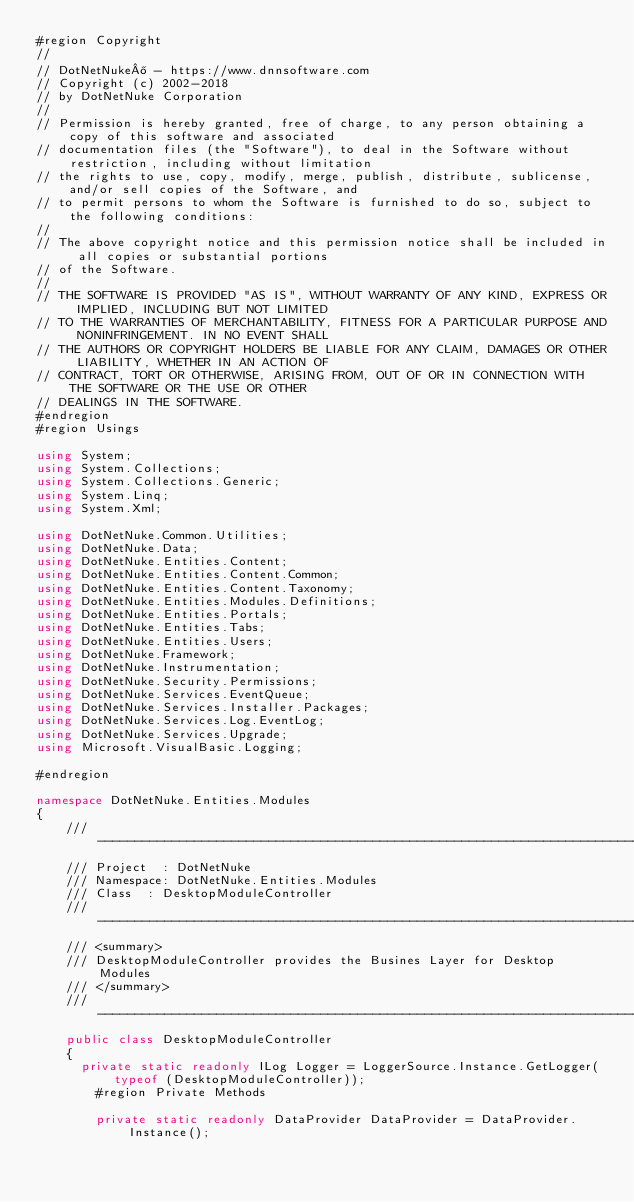<code> <loc_0><loc_0><loc_500><loc_500><_C#_>#region Copyright
// 
// DotNetNuke® - https://www.dnnsoftware.com
// Copyright (c) 2002-2018
// by DotNetNuke Corporation
// 
// Permission is hereby granted, free of charge, to any person obtaining a copy of this software and associated 
// documentation files (the "Software"), to deal in the Software without restriction, including without limitation 
// the rights to use, copy, modify, merge, publish, distribute, sublicense, and/or sell copies of the Software, and 
// to permit persons to whom the Software is furnished to do so, subject to the following conditions:
// 
// The above copyright notice and this permission notice shall be included in all copies or substantial portions 
// of the Software.
// 
// THE SOFTWARE IS PROVIDED "AS IS", WITHOUT WARRANTY OF ANY KIND, EXPRESS OR IMPLIED, INCLUDING BUT NOT LIMITED 
// TO THE WARRANTIES OF MERCHANTABILITY, FITNESS FOR A PARTICULAR PURPOSE AND NONINFRINGEMENT. IN NO EVENT SHALL 
// THE AUTHORS OR COPYRIGHT HOLDERS BE LIABLE FOR ANY CLAIM, DAMAGES OR OTHER LIABILITY, WHETHER IN AN ACTION OF 
// CONTRACT, TORT OR OTHERWISE, ARISING FROM, OUT OF OR IN CONNECTION WITH THE SOFTWARE OR THE USE OR OTHER 
// DEALINGS IN THE SOFTWARE.
#endregion
#region Usings

using System;
using System.Collections;
using System.Collections.Generic;
using System.Linq;
using System.Xml;

using DotNetNuke.Common.Utilities;
using DotNetNuke.Data;
using DotNetNuke.Entities.Content;
using DotNetNuke.Entities.Content.Common;
using DotNetNuke.Entities.Content.Taxonomy;
using DotNetNuke.Entities.Modules.Definitions;
using DotNetNuke.Entities.Portals;
using DotNetNuke.Entities.Tabs;
using DotNetNuke.Entities.Users;
using DotNetNuke.Framework;
using DotNetNuke.Instrumentation;
using DotNetNuke.Security.Permissions;
using DotNetNuke.Services.EventQueue;
using DotNetNuke.Services.Installer.Packages;
using DotNetNuke.Services.Log.EventLog;
using DotNetNuke.Services.Upgrade;
using Microsoft.VisualBasic.Logging;

#endregion

namespace DotNetNuke.Entities.Modules
{
    /// -----------------------------------------------------------------------------
    /// Project	 : DotNetNuke
    /// Namespace: DotNetNuke.Entities.Modules
    /// Class	 : DesktopModuleController
    /// -----------------------------------------------------------------------------
    /// <summary>
    /// DesktopModuleController provides the Busines Layer for Desktop Modules
    /// </summary>
    /// -----------------------------------------------------------------------------
    public class DesktopModuleController
    {
    	private static readonly ILog Logger = LoggerSource.Instance.GetLogger(typeof (DesktopModuleController));
        #region Private Methods

        private static readonly DataProvider DataProvider = DataProvider.Instance();
</code> 